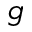<formula> <loc_0><loc_0><loc_500><loc_500>g</formula> 